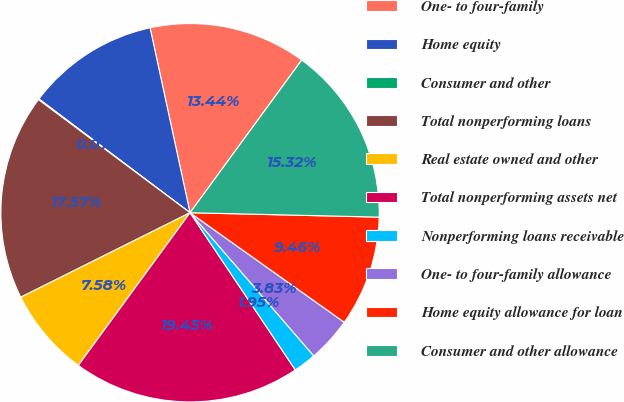<chart> <loc_0><loc_0><loc_500><loc_500><pie_chart><fcel>One- to four-family<fcel>Home equity<fcel>Consumer and other<fcel>Total nonperforming loans<fcel>Real estate owned and other<fcel>Total nonperforming assets net<fcel>Nonperforming loans receivable<fcel>One- to four-family allowance<fcel>Home equity allowance for loan<fcel>Consumer and other allowance<nl><fcel>13.44%<fcel>11.34%<fcel>0.07%<fcel>17.57%<fcel>7.58%<fcel>19.45%<fcel>1.95%<fcel>3.83%<fcel>9.46%<fcel>15.32%<nl></chart> 